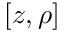<formula> <loc_0><loc_0><loc_500><loc_500>[ z , \rho ]</formula> 